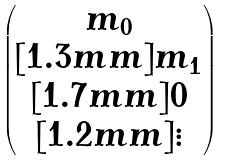<formula> <loc_0><loc_0><loc_500><loc_500>\begin{pmatrix} m _ { 0 } \\ [ 1 . 3 m m ] m _ { 1 } \\ [ 1 . 7 m m ] 0 \\ [ 1 . 2 m m ] \vdots \end{pmatrix}</formula> 